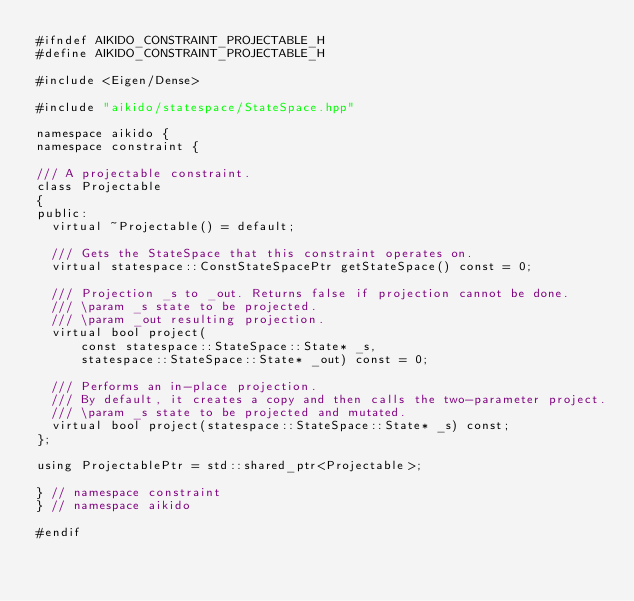<code> <loc_0><loc_0><loc_500><loc_500><_C++_>#ifndef AIKIDO_CONSTRAINT_PROJECTABLE_H
#define AIKIDO_CONSTRAINT_PROJECTABLE_H

#include <Eigen/Dense>

#include "aikido/statespace/StateSpace.hpp"

namespace aikido {
namespace constraint {

/// A projectable constraint.
class Projectable
{
public:
  virtual ~Projectable() = default;

  /// Gets the StateSpace that this constraint operates on.
  virtual statespace::ConstStateSpacePtr getStateSpace() const = 0;

  /// Projection _s to _out. Returns false if projection cannot be done.
  /// \param _s state to be projected.
  /// \param _out resulting projection.
  virtual bool project(
      const statespace::StateSpace::State* _s,
      statespace::StateSpace::State* _out) const = 0;

  /// Performs an in-place projection.
  /// By default, it creates a copy and then calls the two-parameter project.
  /// \param _s state to be projected and mutated.
  virtual bool project(statespace::StateSpace::State* _s) const;
};

using ProjectablePtr = std::shared_ptr<Projectable>;

} // namespace constraint
} // namespace aikido

#endif
</code> 